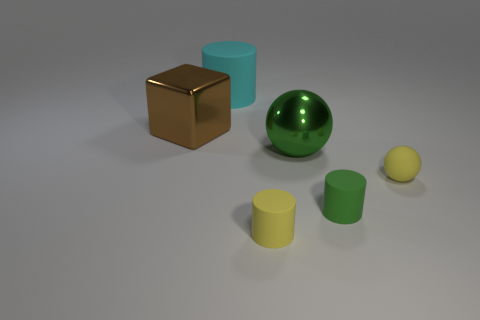What shape is the tiny object that is the same color as the metallic ball?
Make the answer very short. Cylinder. Is there a small ball that has the same material as the green cylinder?
Provide a short and direct response. Yes. Do the yellow thing that is right of the tiny yellow rubber cylinder and the small cylinder that is on the right side of the tiny yellow matte cylinder have the same material?
Your answer should be very brief. Yes. Is the number of tiny matte spheres left of the yellow matte cylinder the same as the number of large cyan matte cylinders to the left of the cube?
Offer a terse response. Yes. There is a rubber ball that is the same size as the green rubber cylinder; what color is it?
Make the answer very short. Yellow. Are there any small cylinders of the same color as the large cube?
Offer a very short reply. No. What number of things are objects that are to the right of the big shiny block or big shiny blocks?
Your response must be concise. 6. What number of other objects are the same size as the green sphere?
Your answer should be very brief. 2. The small cylinder that is right of the yellow object that is left of the ball that is behind the tiny yellow ball is made of what material?
Your answer should be compact. Rubber. How many spheres are green things or tiny matte objects?
Make the answer very short. 2. 